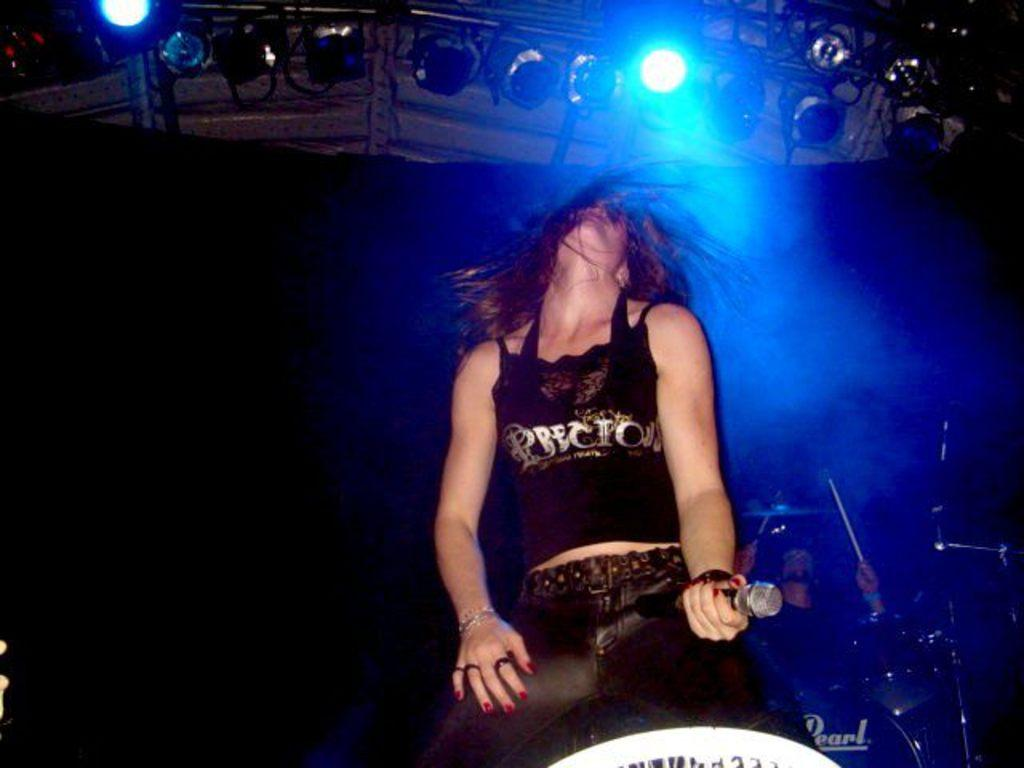Who is the main subject in the image? There is a girl in the image. What is the girl wearing? The girl is wearing a black top and jeans. What is the girl doing in the image? The girl is singing on the stage. What can be seen behind the girl? There is a band behind the girl. What color are the spotlights visible at the top of the image? There are blue color spotlights visible at the top of the image. Can you see a toy in the girl's hand while she is singing? There is no toy visible in the girl's hand in the image. Is there a fire on the stage during the girl's performance? There is no fire visible on the stage in the image. 